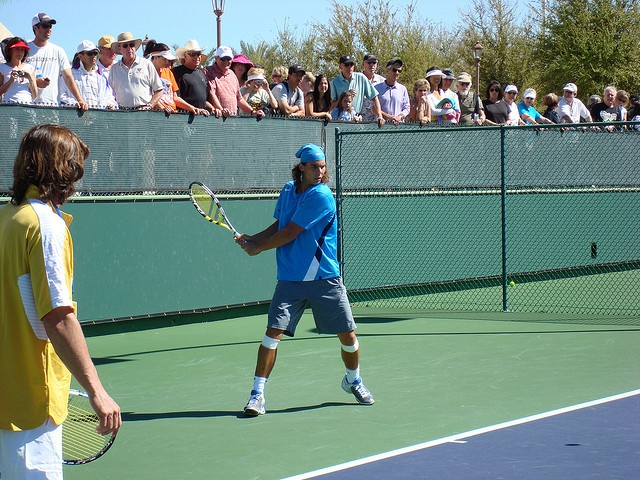Describe the objects in this image and their specific colors. I can see people in lightblue, olive, white, black, and maroon tones, people in lightblue, white, black, gray, and olive tones, people in lightblue, black, blue, and navy tones, people in lightblue, white, darkgray, and gray tones, and tennis racket in lightblue, olive, green, teal, and khaki tones in this image. 